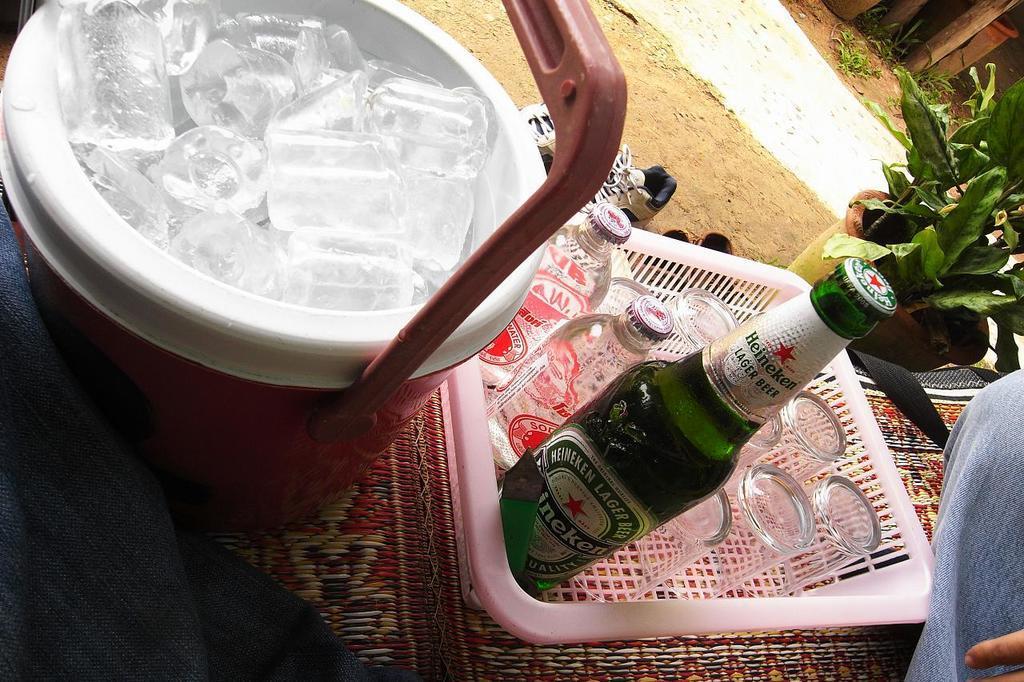Could you give a brief overview of what you see in this image? In this image I see a bowl of ice and a tray of glasses and bottles. In the background I see a plant and a path. 